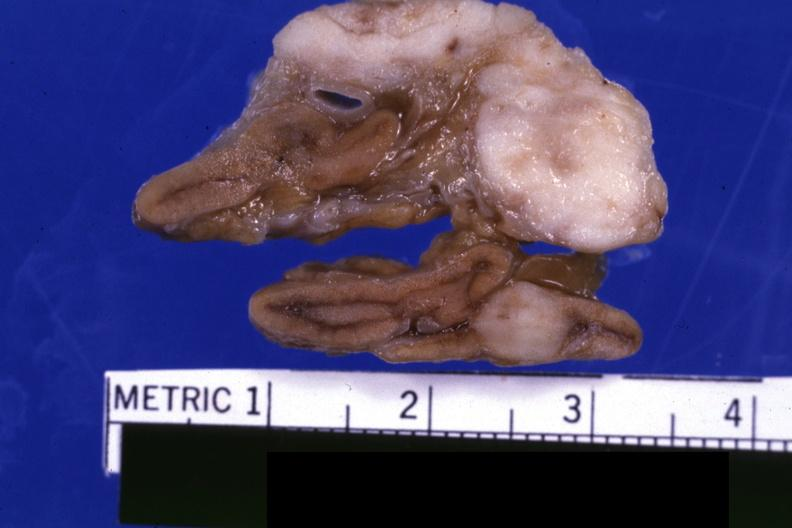does amyloidosis show fixed tissue close-up view shows tumor very well lung adenocarcinoma?
Answer the question using a single word or phrase. No 